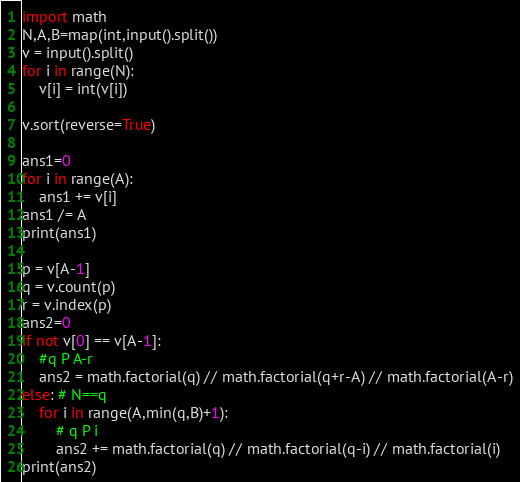Convert code to text. <code><loc_0><loc_0><loc_500><loc_500><_Python_>import math
N,A,B=map(int,input().split())
v = input().split()
for i in range(N):
    v[i] = int(v[i])

v.sort(reverse=True)

ans1=0
for i in range(A):
    ans1 += v[i]
ans1 /= A
print(ans1)

p = v[A-1]
q = v.count(p)
r = v.index(p)
ans2=0
if not v[0] == v[A-1]:
    #q P A-r
    ans2 = math.factorial(q) // math.factorial(q+r-A) // math.factorial(A-r)
else: # N==q
    for i in range(A,min(q,B)+1):
        # q P i
        ans2 += math.factorial(q) // math.factorial(q-i) // math.factorial(i)
print(ans2)
</code> 